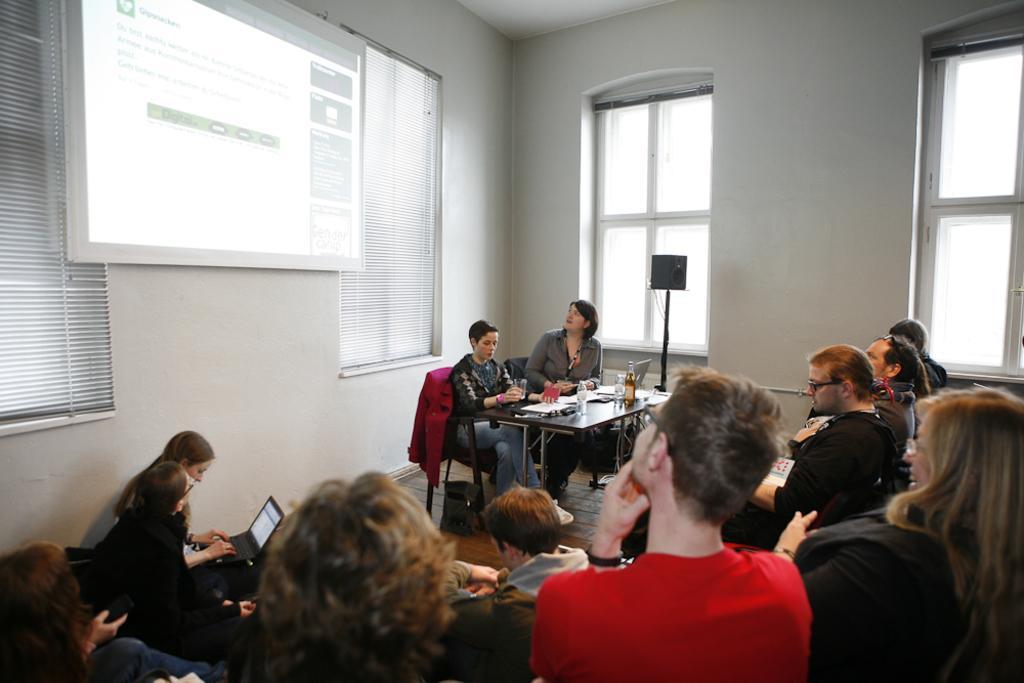Describe this image in one or two sentences. In this picture we can see a group of people holding laptops in their hands and in front of them two women sitting on chair and in front of this two woman we have laptop, bottle, papers on table and in background we can see screen, wall, windows, stand. 